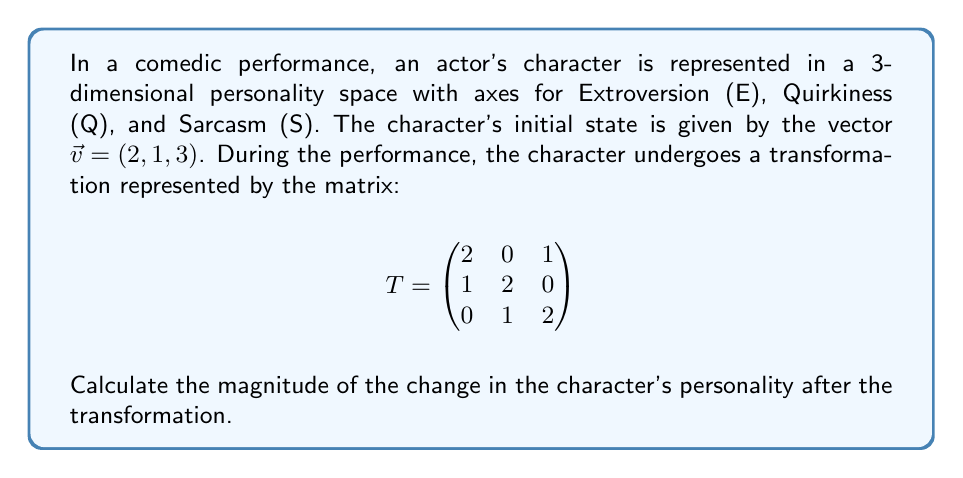Show me your answer to this math problem. To solve this problem, we'll follow these steps:

1) First, we need to apply the transformation matrix to the initial character vector:

   $\vec{v}_{new} = T\vec{v}$

   $$\begin{pmatrix}
   2 & 0 & 1 \\
   1 & 2 & 0 \\
   0 & 1 & 2
   \end{pmatrix} \begin{pmatrix}
   2 \\
   1 \\
   3
   \end{pmatrix} = \begin{pmatrix}
   (2 \cdot 2 + 0 \cdot 1 + 1 \cdot 3) \\
   (1 \cdot 2 + 2 \cdot 1 + 0 \cdot 3) \\
   (0 \cdot 2 + 1 \cdot 1 + 2 \cdot 3)
   \end{pmatrix} = \begin{pmatrix}
   7 \\
   4 \\
   7
   \end{pmatrix}$$

2) Now we have the new character vector $\vec{v}_{new} = (7, 4, 7)$

3) To find the change in personality, we subtract the initial vector from the new vector:

   $\Delta\vec{v} = \vec{v}_{new} - \vec{v} = (7, 4, 7) - (2, 1, 3) = (5, 3, 4)$

4) The magnitude of this change is the length of the $\Delta\vec{v}$ vector, which we can calculate using the Euclidean norm:

   $\|\Delta\vec{v}\| = \sqrt{(\Delta E)^2 + (\Delta Q)^2 + (\Delta S)^2}$

   $\|\Delta\vec{v}\| = \sqrt{5^2 + 3^2 + 4^2} = \sqrt{25 + 9 + 16} = \sqrt{50}$

5) Simplify the square root:

   $\sqrt{50} = 5\sqrt{2}$

Therefore, the magnitude of the change in the character's personality is $5\sqrt{2}$.
Answer: $5\sqrt{2}$ 